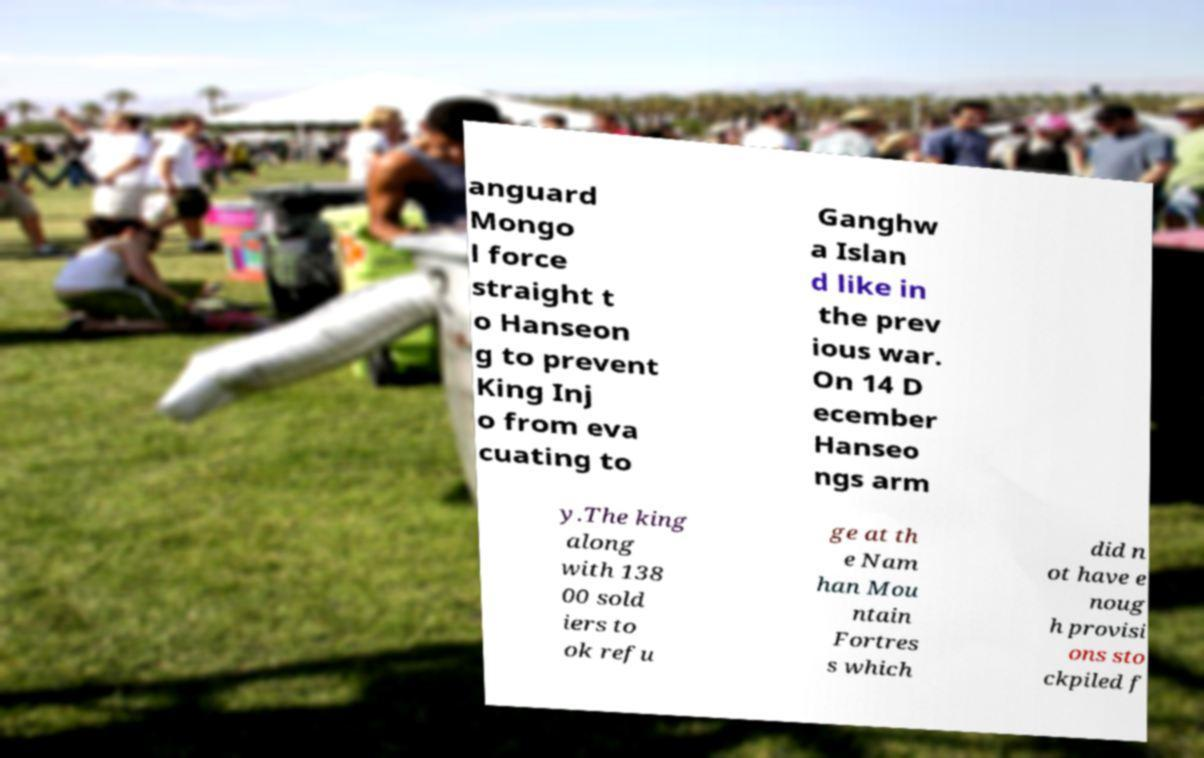Can you accurately transcribe the text from the provided image for me? anguard Mongo l force straight t o Hanseon g to prevent King Inj o from eva cuating to Ganghw a Islan d like in the prev ious war. On 14 D ecember Hanseo ngs arm y.The king along with 138 00 sold iers to ok refu ge at th e Nam han Mou ntain Fortres s which did n ot have e noug h provisi ons sto ckpiled f 